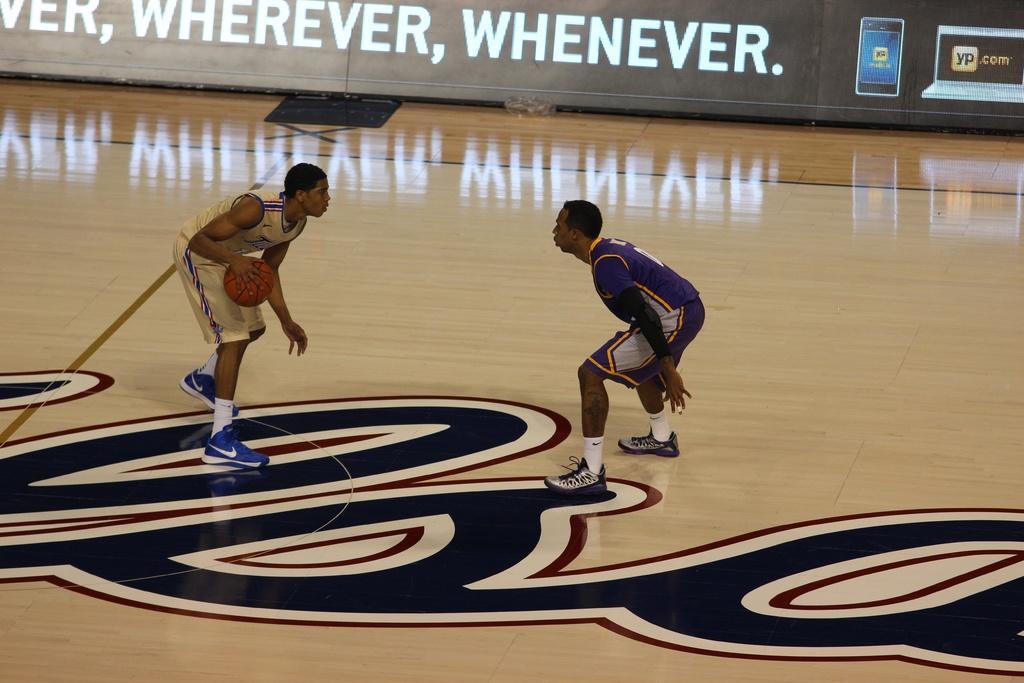Describe this image in one or two sentences. In this picture we can observe two basketball players playing basketball in the court. The court is in cream color. One of them was holding a basketball in his hand. In the background we can observe a black color wall on which there are white color words written. 